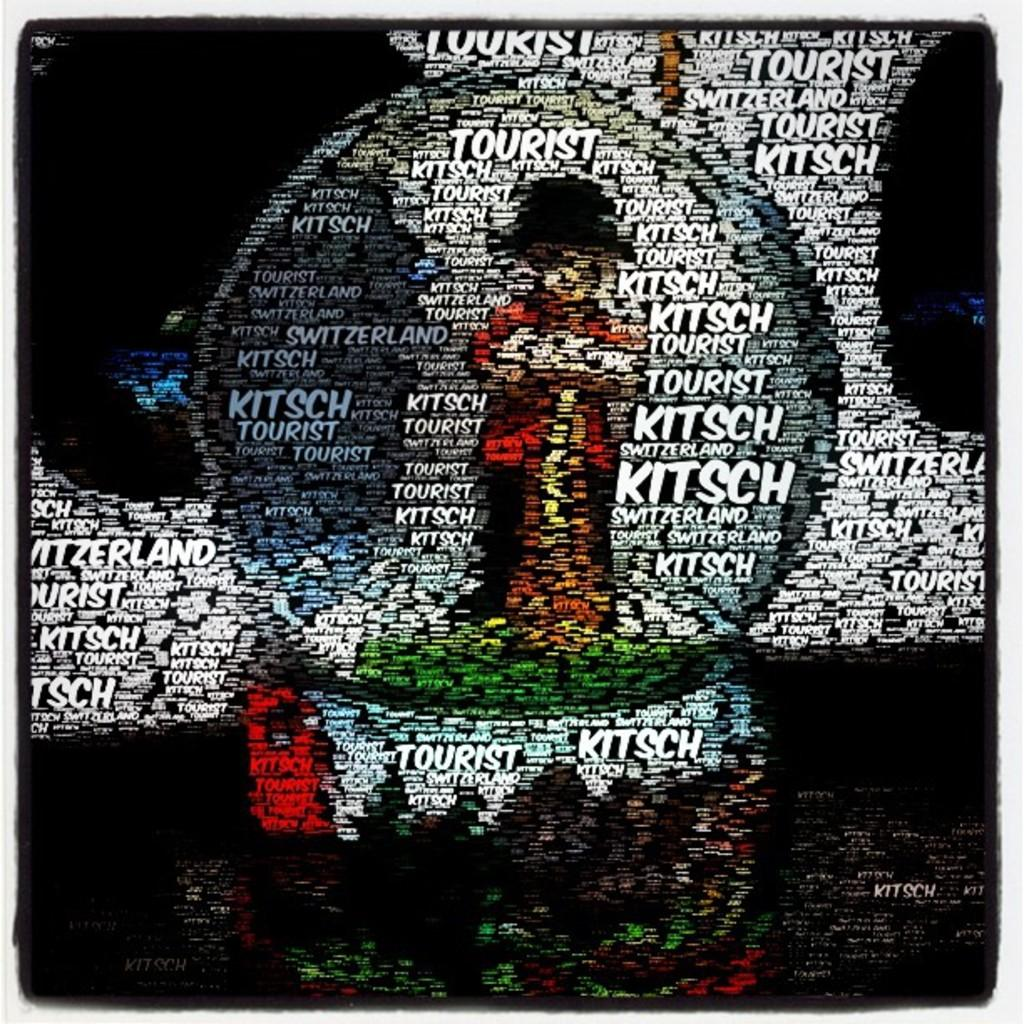<image>
Relay a brief, clear account of the picture shown. A language graphic repeatedly shows the word "kitsch". 